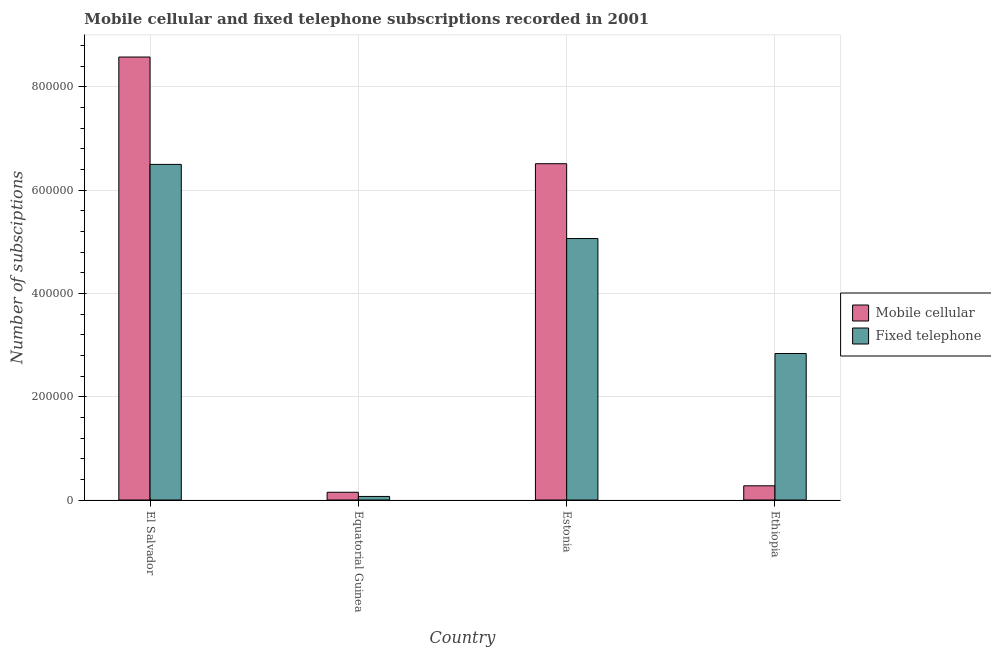Are the number of bars per tick equal to the number of legend labels?
Provide a short and direct response. Yes. What is the label of the 3rd group of bars from the left?
Offer a very short reply. Estonia. What is the number of mobile cellular subscriptions in Equatorial Guinea?
Your answer should be compact. 1.50e+04. Across all countries, what is the maximum number of fixed telephone subscriptions?
Your response must be concise. 6.50e+05. Across all countries, what is the minimum number of mobile cellular subscriptions?
Your answer should be compact. 1.50e+04. In which country was the number of fixed telephone subscriptions maximum?
Provide a succinct answer. El Salvador. In which country was the number of fixed telephone subscriptions minimum?
Offer a terse response. Equatorial Guinea. What is the total number of mobile cellular subscriptions in the graph?
Give a very brief answer. 1.55e+06. What is the difference between the number of fixed telephone subscriptions in Equatorial Guinea and that in Ethiopia?
Make the answer very short. -2.77e+05. What is the difference between the number of mobile cellular subscriptions in Estonia and the number of fixed telephone subscriptions in Equatorial Guinea?
Provide a short and direct response. 6.44e+05. What is the average number of fixed telephone subscriptions per country?
Provide a succinct answer. 3.62e+05. What is the difference between the number of mobile cellular subscriptions and number of fixed telephone subscriptions in Estonia?
Keep it short and to the point. 1.45e+05. In how many countries, is the number of fixed telephone subscriptions greater than 120000 ?
Keep it short and to the point. 3. What is the ratio of the number of mobile cellular subscriptions in Equatorial Guinea to that in Ethiopia?
Your response must be concise. 0.55. What is the difference between the highest and the second highest number of fixed telephone subscriptions?
Your answer should be very brief. 1.44e+05. What is the difference between the highest and the lowest number of fixed telephone subscriptions?
Your answer should be compact. 6.43e+05. Is the sum of the number of fixed telephone subscriptions in El Salvador and Equatorial Guinea greater than the maximum number of mobile cellular subscriptions across all countries?
Provide a short and direct response. No. What does the 1st bar from the left in El Salvador represents?
Your response must be concise. Mobile cellular. What does the 1st bar from the right in Estonia represents?
Provide a succinct answer. Fixed telephone. How many countries are there in the graph?
Your answer should be compact. 4. What is the difference between two consecutive major ticks on the Y-axis?
Make the answer very short. 2.00e+05. Are the values on the major ticks of Y-axis written in scientific E-notation?
Offer a terse response. No. Does the graph contain any zero values?
Offer a terse response. No. How are the legend labels stacked?
Provide a succinct answer. Vertical. What is the title of the graph?
Provide a short and direct response. Mobile cellular and fixed telephone subscriptions recorded in 2001. Does "Time to import" appear as one of the legend labels in the graph?
Provide a short and direct response. No. What is the label or title of the X-axis?
Your response must be concise. Country. What is the label or title of the Y-axis?
Your response must be concise. Number of subsciptions. What is the Number of subsciptions in Mobile cellular in El Salvador?
Keep it short and to the point. 8.58e+05. What is the Number of subsciptions in Fixed telephone in El Salvador?
Make the answer very short. 6.50e+05. What is the Number of subsciptions in Mobile cellular in Equatorial Guinea?
Keep it short and to the point. 1.50e+04. What is the Number of subsciptions in Fixed telephone in Equatorial Guinea?
Ensure brevity in your answer.  6900. What is the Number of subsciptions in Mobile cellular in Estonia?
Make the answer very short. 6.51e+05. What is the Number of subsciptions of Fixed telephone in Estonia?
Offer a terse response. 5.06e+05. What is the Number of subsciptions in Mobile cellular in Ethiopia?
Offer a very short reply. 2.75e+04. What is the Number of subsciptions of Fixed telephone in Ethiopia?
Ensure brevity in your answer.  2.84e+05. Across all countries, what is the maximum Number of subsciptions in Mobile cellular?
Provide a succinct answer. 8.58e+05. Across all countries, what is the maximum Number of subsciptions of Fixed telephone?
Provide a short and direct response. 6.50e+05. Across all countries, what is the minimum Number of subsciptions in Mobile cellular?
Keep it short and to the point. 1.50e+04. Across all countries, what is the minimum Number of subsciptions of Fixed telephone?
Your response must be concise. 6900. What is the total Number of subsciptions of Mobile cellular in the graph?
Your answer should be very brief. 1.55e+06. What is the total Number of subsciptions in Fixed telephone in the graph?
Provide a short and direct response. 1.45e+06. What is the difference between the Number of subsciptions of Mobile cellular in El Salvador and that in Equatorial Guinea?
Make the answer very short. 8.43e+05. What is the difference between the Number of subsciptions of Fixed telephone in El Salvador and that in Equatorial Guinea?
Offer a terse response. 6.43e+05. What is the difference between the Number of subsciptions of Mobile cellular in El Salvador and that in Estonia?
Keep it short and to the point. 2.07e+05. What is the difference between the Number of subsciptions of Fixed telephone in El Salvador and that in Estonia?
Ensure brevity in your answer.  1.44e+05. What is the difference between the Number of subsciptions of Mobile cellular in El Salvador and that in Ethiopia?
Offer a very short reply. 8.30e+05. What is the difference between the Number of subsciptions in Fixed telephone in El Salvador and that in Ethiopia?
Ensure brevity in your answer.  3.66e+05. What is the difference between the Number of subsciptions in Mobile cellular in Equatorial Guinea and that in Estonia?
Give a very brief answer. -6.36e+05. What is the difference between the Number of subsciptions in Fixed telephone in Equatorial Guinea and that in Estonia?
Ensure brevity in your answer.  -4.99e+05. What is the difference between the Number of subsciptions in Mobile cellular in Equatorial Guinea and that in Ethiopia?
Your answer should be very brief. -1.25e+04. What is the difference between the Number of subsciptions of Fixed telephone in Equatorial Guinea and that in Ethiopia?
Provide a succinct answer. -2.77e+05. What is the difference between the Number of subsciptions of Mobile cellular in Estonia and that in Ethiopia?
Make the answer very short. 6.24e+05. What is the difference between the Number of subsciptions of Fixed telephone in Estonia and that in Ethiopia?
Provide a succinct answer. 2.23e+05. What is the difference between the Number of subsciptions of Mobile cellular in El Salvador and the Number of subsciptions of Fixed telephone in Equatorial Guinea?
Give a very brief answer. 8.51e+05. What is the difference between the Number of subsciptions in Mobile cellular in El Salvador and the Number of subsciptions in Fixed telephone in Estonia?
Offer a very short reply. 3.51e+05. What is the difference between the Number of subsciptions in Mobile cellular in El Salvador and the Number of subsciptions in Fixed telephone in Ethiopia?
Offer a very short reply. 5.74e+05. What is the difference between the Number of subsciptions of Mobile cellular in Equatorial Guinea and the Number of subsciptions of Fixed telephone in Estonia?
Your answer should be compact. -4.91e+05. What is the difference between the Number of subsciptions in Mobile cellular in Equatorial Guinea and the Number of subsciptions in Fixed telephone in Ethiopia?
Your response must be concise. -2.69e+05. What is the difference between the Number of subsciptions in Mobile cellular in Estonia and the Number of subsciptions in Fixed telephone in Ethiopia?
Keep it short and to the point. 3.68e+05. What is the average Number of subsciptions in Mobile cellular per country?
Provide a short and direct response. 3.88e+05. What is the average Number of subsciptions of Fixed telephone per country?
Your response must be concise. 3.62e+05. What is the difference between the Number of subsciptions in Mobile cellular and Number of subsciptions in Fixed telephone in El Salvador?
Ensure brevity in your answer.  2.08e+05. What is the difference between the Number of subsciptions in Mobile cellular and Number of subsciptions in Fixed telephone in Equatorial Guinea?
Your answer should be compact. 8100. What is the difference between the Number of subsciptions of Mobile cellular and Number of subsciptions of Fixed telephone in Estonia?
Offer a terse response. 1.45e+05. What is the difference between the Number of subsciptions of Mobile cellular and Number of subsciptions of Fixed telephone in Ethiopia?
Give a very brief answer. -2.56e+05. What is the ratio of the Number of subsciptions of Mobile cellular in El Salvador to that in Equatorial Guinea?
Ensure brevity in your answer.  57.19. What is the ratio of the Number of subsciptions of Fixed telephone in El Salvador to that in Equatorial Guinea?
Provide a succinct answer. 94.19. What is the ratio of the Number of subsciptions in Mobile cellular in El Salvador to that in Estonia?
Your answer should be compact. 1.32. What is the ratio of the Number of subsciptions of Fixed telephone in El Salvador to that in Estonia?
Your answer should be very brief. 1.28. What is the ratio of the Number of subsciptions in Mobile cellular in El Salvador to that in Ethiopia?
Offer a very short reply. 31.19. What is the ratio of the Number of subsciptions of Fixed telephone in El Salvador to that in Ethiopia?
Your response must be concise. 2.29. What is the ratio of the Number of subsciptions in Mobile cellular in Equatorial Guinea to that in Estonia?
Make the answer very short. 0.02. What is the ratio of the Number of subsciptions in Fixed telephone in Equatorial Guinea to that in Estonia?
Ensure brevity in your answer.  0.01. What is the ratio of the Number of subsciptions in Mobile cellular in Equatorial Guinea to that in Ethiopia?
Keep it short and to the point. 0.55. What is the ratio of the Number of subsciptions in Fixed telephone in Equatorial Guinea to that in Ethiopia?
Offer a terse response. 0.02. What is the ratio of the Number of subsciptions of Mobile cellular in Estonia to that in Ethiopia?
Your answer should be compact. 23.68. What is the ratio of the Number of subsciptions in Fixed telephone in Estonia to that in Ethiopia?
Offer a terse response. 1.78. What is the difference between the highest and the second highest Number of subsciptions of Mobile cellular?
Offer a very short reply. 2.07e+05. What is the difference between the highest and the second highest Number of subsciptions in Fixed telephone?
Make the answer very short. 1.44e+05. What is the difference between the highest and the lowest Number of subsciptions in Mobile cellular?
Make the answer very short. 8.43e+05. What is the difference between the highest and the lowest Number of subsciptions of Fixed telephone?
Provide a short and direct response. 6.43e+05. 